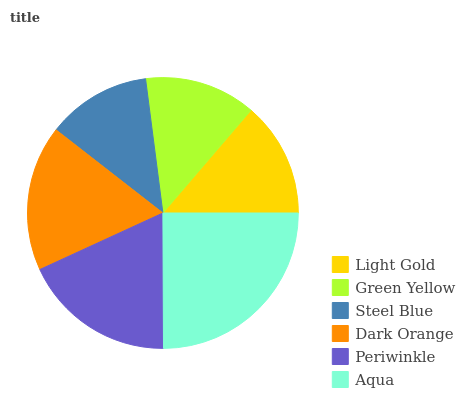Is Steel Blue the minimum?
Answer yes or no. Yes. Is Aqua the maximum?
Answer yes or no. Yes. Is Green Yellow the minimum?
Answer yes or no. No. Is Green Yellow the maximum?
Answer yes or no. No. Is Light Gold greater than Green Yellow?
Answer yes or no. Yes. Is Green Yellow less than Light Gold?
Answer yes or no. Yes. Is Green Yellow greater than Light Gold?
Answer yes or no. No. Is Light Gold less than Green Yellow?
Answer yes or no. No. Is Dark Orange the high median?
Answer yes or no. Yes. Is Light Gold the low median?
Answer yes or no. Yes. Is Aqua the high median?
Answer yes or no. No. Is Green Yellow the low median?
Answer yes or no. No. 